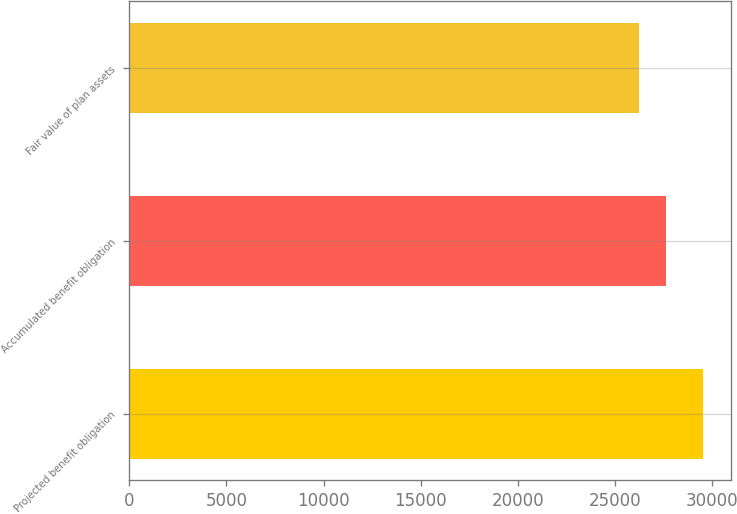Convert chart to OTSL. <chart><loc_0><loc_0><loc_500><loc_500><bar_chart><fcel>Projected benefit obligation<fcel>Accumulated benefit obligation<fcel>Fair value of plan assets<nl><fcel>29508<fcel>27623<fcel>26224<nl></chart> 